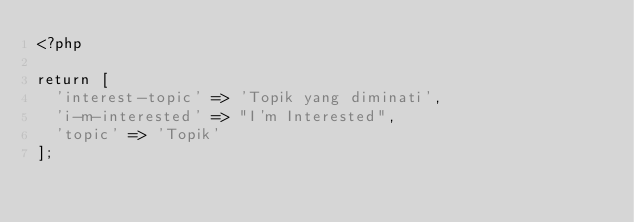Convert code to text. <code><loc_0><loc_0><loc_500><loc_500><_PHP_><?php

return [
	'interest-topic' => 'Topik yang diminati',
	'i-m-interested' => "I'm Interested",
	'topic' => 'Topik'
];</code> 